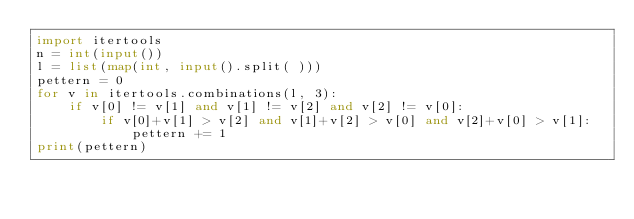<code> <loc_0><loc_0><loc_500><loc_500><_Python_>import itertools
n = int(input())
l = list(map(int, input().split( )))
pettern = 0
for v in itertools.combinations(l, 3):
    if v[0] != v[1] and v[1] != v[2] and v[2] != v[0]:
        if v[0]+v[1] > v[2] and v[1]+v[2] > v[0] and v[2]+v[0] > v[1]:
            pettern += 1
print(pettern)
</code> 